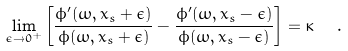<formula> <loc_0><loc_0><loc_500><loc_500>\lim _ { \epsilon \rightarrow 0 ^ { + } } \left [ \frac { \phi ^ { \prime } ( \omega , x _ { s } + \epsilon ) } { \phi ( \omega , x _ { s } + \epsilon ) } - \frac { \phi ^ { \prime } ( \omega , x _ { s } - \epsilon ) } { \phi ( \omega , x _ { s } - \epsilon ) } \right ] = \kappa \ \ .</formula> 